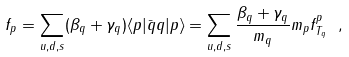Convert formula to latex. <formula><loc_0><loc_0><loc_500><loc_500>f _ { p } = \sum _ { u , d , s } ( \beta _ { q } + \gamma _ { q } ) \langle p | \bar { q } q | p \rangle = \sum _ { u , d , s } \frac { \beta _ { q } + \gamma _ { q } } { m _ { q } } m _ { p } f ^ { p } _ { T _ { q } } \ ,</formula> 